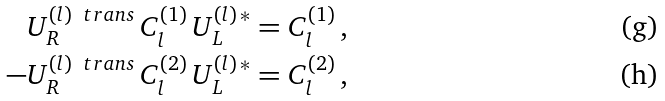Convert formula to latex. <formula><loc_0><loc_0><loc_500><loc_500>U _ { R } ^ { ( l ) \, \ t r a n s } \, C ^ { ( 1 ) } _ { l } \, U _ { L } ^ { ( l ) \, \ast } & = C ^ { ( 1 ) } _ { l } \, , \\ - U _ { R } ^ { ( l ) \, \ t r a n s } \, C ^ { ( 2 ) } _ { l } \, U _ { L } ^ { ( l ) \, \ast } & = C ^ { ( 2 ) } _ { l } \, ,</formula> 